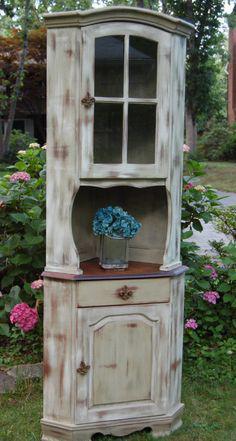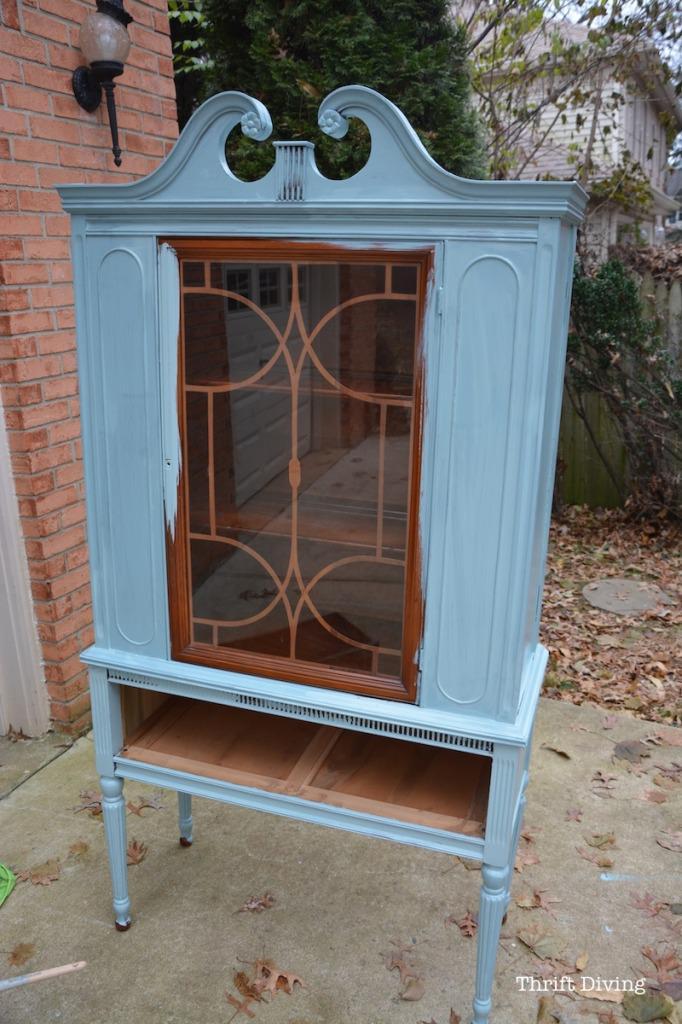The first image is the image on the left, the second image is the image on the right. Analyze the images presented: Is the assertion "An image shows a white cabinet with a decorative top element, centered glass panel, and slender legs." valid? Answer yes or no. No. 